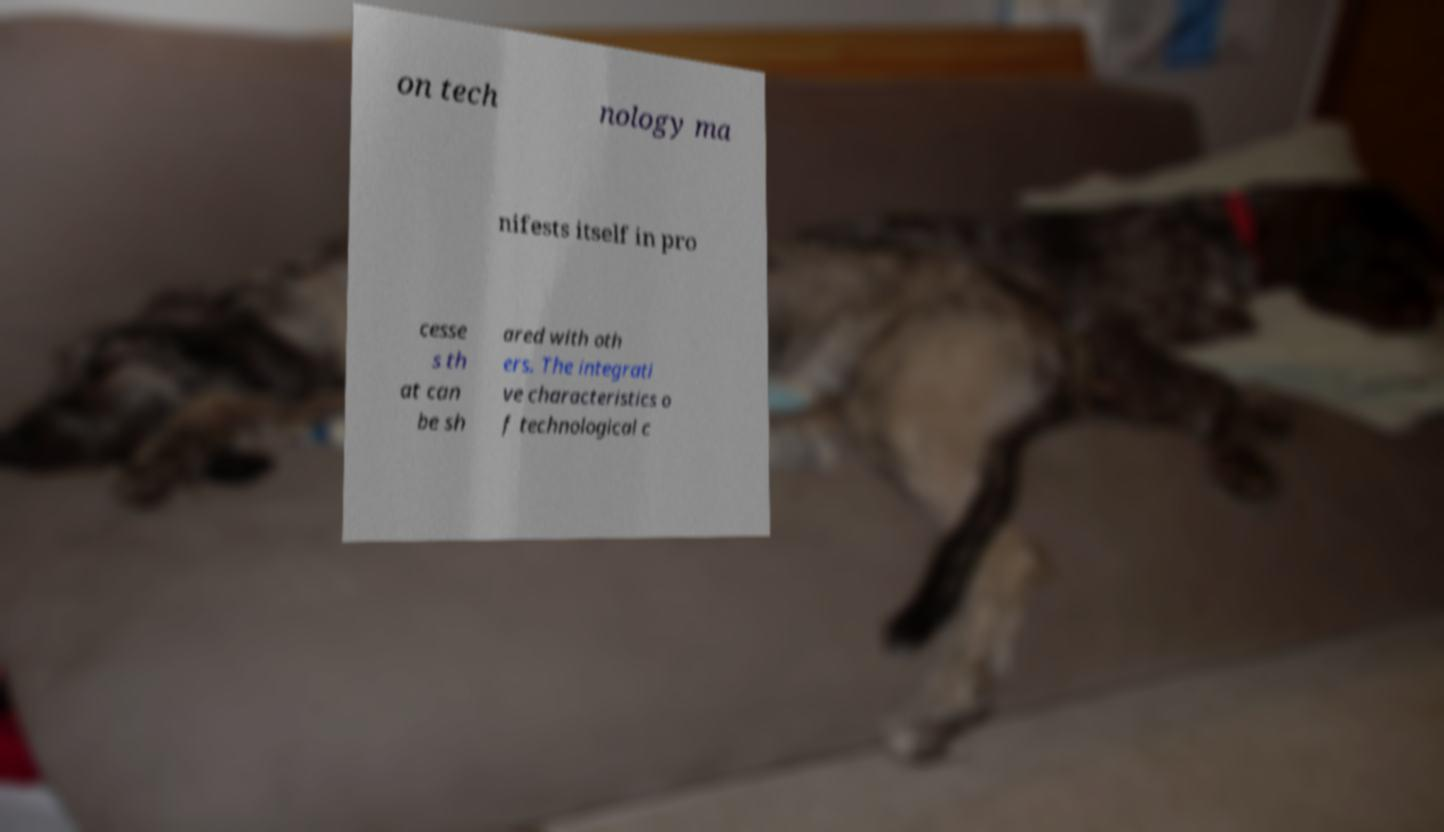Please identify and transcribe the text found in this image. on tech nology ma nifests itself in pro cesse s th at can be sh ared with oth ers. The integrati ve characteristics o f technological c 